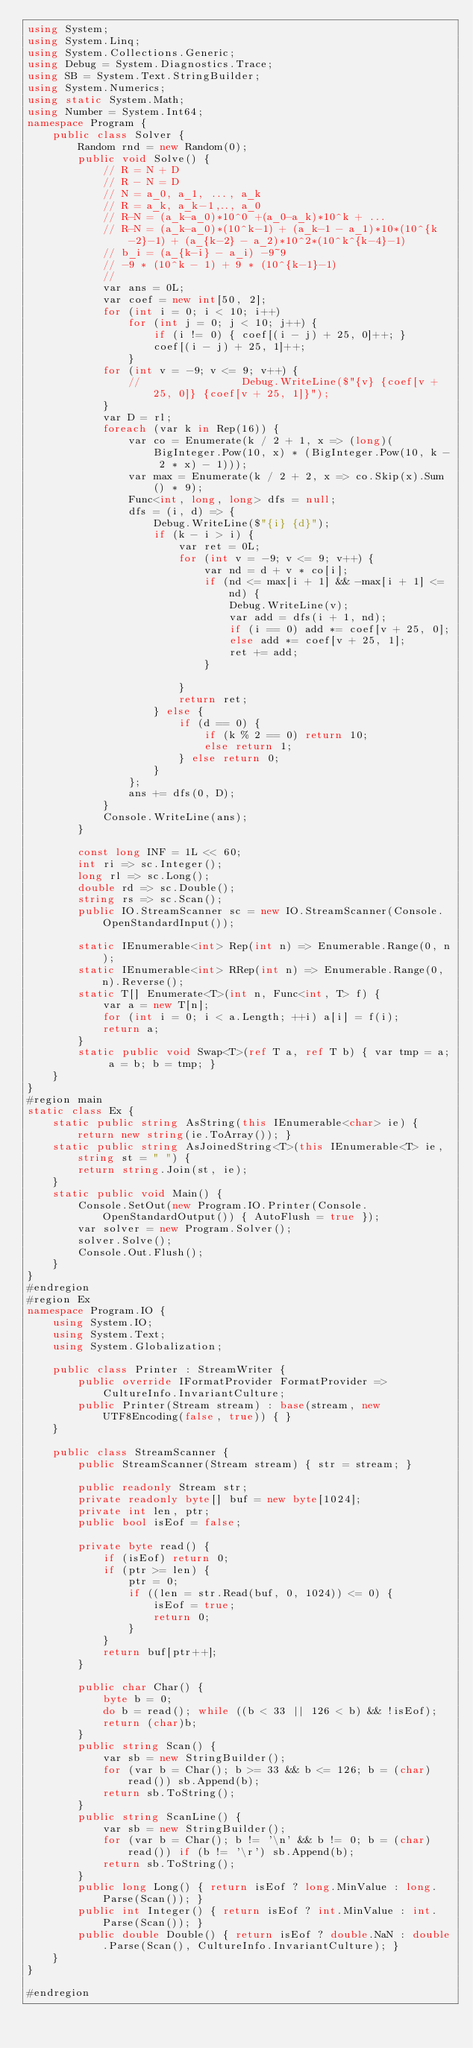Convert code to text. <code><loc_0><loc_0><loc_500><loc_500><_C#_>using System;
using System.Linq;
using System.Collections.Generic;
using Debug = System.Diagnostics.Trace;
using SB = System.Text.StringBuilder;
using System.Numerics;
using static System.Math;
using Number = System.Int64;
namespace Program {
    public class Solver {
        Random rnd = new Random(0);
        public void Solve() {
            // R = N + D
            // R - N = D
            // N = a_0, a_1, ..., a_k
            // R = a_k, a_k-1,.., a_0
            // R-N = (a_k-a_0)*10^0 +(a_0-a_k)*10^k + ...
            // R-N = (a_k-a_0)*(10^k-1) + (a_k-1 - a_1)*10*(10^{k-2}-1) + (a_{k-2} - a_2)*10^2*(10^k^{k-4}-1)
            // b_i = (a_{k-i} - a_i) -9~9
            // -9 * (10^k - 1) + 9 * (10^{k-1}-1)
            // 
            var ans = 0L;
            var coef = new int[50, 2];
            for (int i = 0; i < 10; i++)
                for (int j = 0; j < 10; j++) {
                    if (i != 0) { coef[(i - j) + 25, 0]++; }
                    coef[(i - j) + 25, 1]++;
                }
            for (int v = -9; v <= 9; v++) {
                //                Debug.WriteLine($"{v} {coef[v + 25, 0]} {coef[v + 25, 1]}");
            }
            var D = rl;
            foreach (var k in Rep(16)) {
                var co = Enumerate(k / 2 + 1, x => (long)(BigInteger.Pow(10, x) * (BigInteger.Pow(10, k - 2 * x) - 1)));
                var max = Enumerate(k / 2 + 2, x => co.Skip(x).Sum() * 9);
                Func<int, long, long> dfs = null;
                dfs = (i, d) => {
                    Debug.WriteLine($"{i} {d}");
                    if (k - i > i) {
                        var ret = 0L;
                        for (int v = -9; v <= 9; v++) {
                            var nd = d + v * co[i];
                            if (nd <= max[i + 1] && -max[i + 1] <= nd) {
                                Debug.WriteLine(v);
                                var add = dfs(i + 1, nd);
                                if (i == 0) add *= coef[v + 25, 0];
                                else add *= coef[v + 25, 1];
                                ret += add;
                            }

                        }
                        return ret;
                    } else {
                        if (d == 0) {
                            if (k % 2 == 0) return 10;
                            else return 1;
                        } else return 0;
                    }
                };
                ans += dfs(0, D);
            }
            Console.WriteLine(ans);
        }

        const long INF = 1L << 60;
        int ri => sc.Integer();
        long rl => sc.Long();
        double rd => sc.Double();
        string rs => sc.Scan();
        public IO.StreamScanner sc = new IO.StreamScanner(Console.OpenStandardInput());

        static IEnumerable<int> Rep(int n) => Enumerable.Range(0, n);
        static IEnumerable<int> RRep(int n) => Enumerable.Range(0, n).Reverse();
        static T[] Enumerate<T>(int n, Func<int, T> f) {
            var a = new T[n];
            for (int i = 0; i < a.Length; ++i) a[i] = f(i);
            return a;
        }
        static public void Swap<T>(ref T a, ref T b) { var tmp = a; a = b; b = tmp; }
    }
}
#region main
static class Ex {
    static public string AsString(this IEnumerable<char> ie) { return new string(ie.ToArray()); }
    static public string AsJoinedString<T>(this IEnumerable<T> ie, string st = " ") {
        return string.Join(st, ie);
    }
    static public void Main() {
        Console.SetOut(new Program.IO.Printer(Console.OpenStandardOutput()) { AutoFlush = true });
        var solver = new Program.Solver();
        solver.Solve();
        Console.Out.Flush();
    }
}
#endregion
#region Ex
namespace Program.IO {
    using System.IO;
    using System.Text;
    using System.Globalization;

    public class Printer : StreamWriter {
        public override IFormatProvider FormatProvider => CultureInfo.InvariantCulture;
        public Printer(Stream stream) : base(stream, new UTF8Encoding(false, true)) { }
    }

    public class StreamScanner {
        public StreamScanner(Stream stream) { str = stream; }

        public readonly Stream str;
        private readonly byte[] buf = new byte[1024];
        private int len, ptr;
        public bool isEof = false;

        private byte read() {
            if (isEof) return 0;
            if (ptr >= len) {
                ptr = 0;
                if ((len = str.Read(buf, 0, 1024)) <= 0) {
                    isEof = true;
                    return 0;
                }
            }
            return buf[ptr++];
        }

        public char Char() {
            byte b = 0;
            do b = read(); while ((b < 33 || 126 < b) && !isEof);
            return (char)b;
        }
        public string Scan() {
            var sb = new StringBuilder();
            for (var b = Char(); b >= 33 && b <= 126; b = (char)read()) sb.Append(b);
            return sb.ToString();
        }
        public string ScanLine() {
            var sb = new StringBuilder();
            for (var b = Char(); b != '\n' && b != 0; b = (char)read()) if (b != '\r') sb.Append(b);
            return sb.ToString();
        }
        public long Long() { return isEof ? long.MinValue : long.Parse(Scan()); }
        public int Integer() { return isEof ? int.MinValue : int.Parse(Scan()); }
        public double Double() { return isEof ? double.NaN : double.Parse(Scan(), CultureInfo.InvariantCulture); }
    }
}

#endregion
</code> 